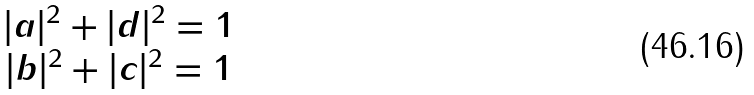<formula> <loc_0><loc_0><loc_500><loc_500>\begin{matrix} | a | ^ { 2 } + | d | ^ { 2 } = 1 \\ | b | ^ { 2 } + | c | ^ { 2 } = 1 \end{matrix}</formula> 